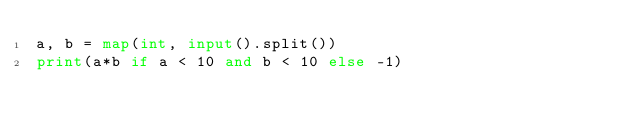Convert code to text. <code><loc_0><loc_0><loc_500><loc_500><_Python_>a, b = map(int, input().split())
print(a*b if a < 10 and b < 10 else -1)</code> 